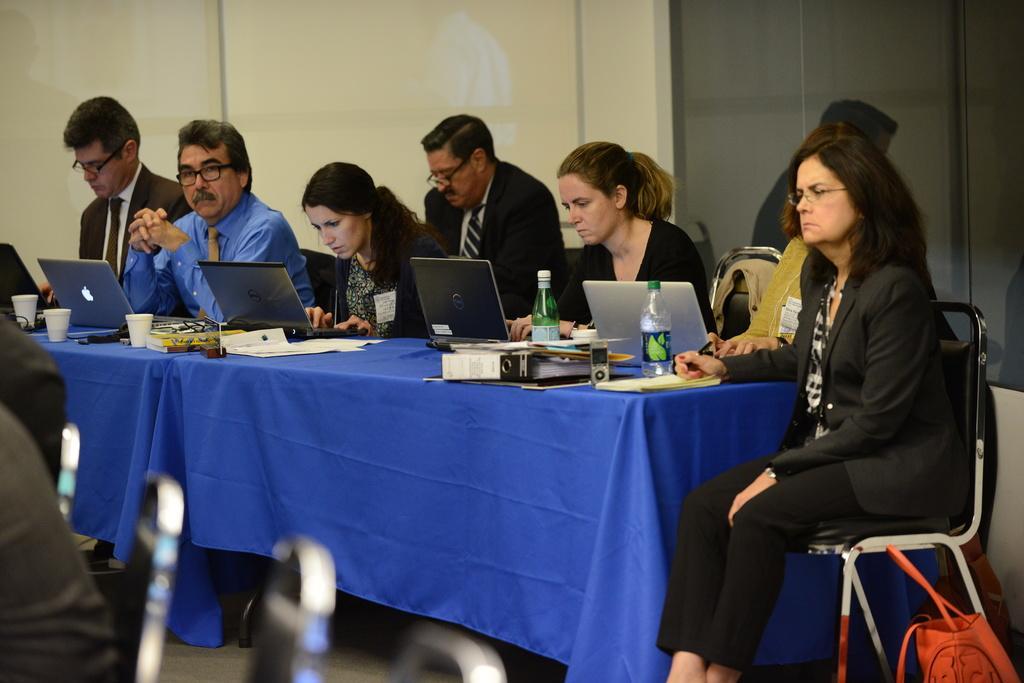Could you give a brief overview of what you see in this image? In the picture we can see six people sitting on a chairs near the table. The table is covered with table cloth which is blue in color on it we can see a four laptops and bottles and glasses, and some papers on it. In the background also we can see a person sitting on the chair, and a wall which is with in color and some part is dark in color. 